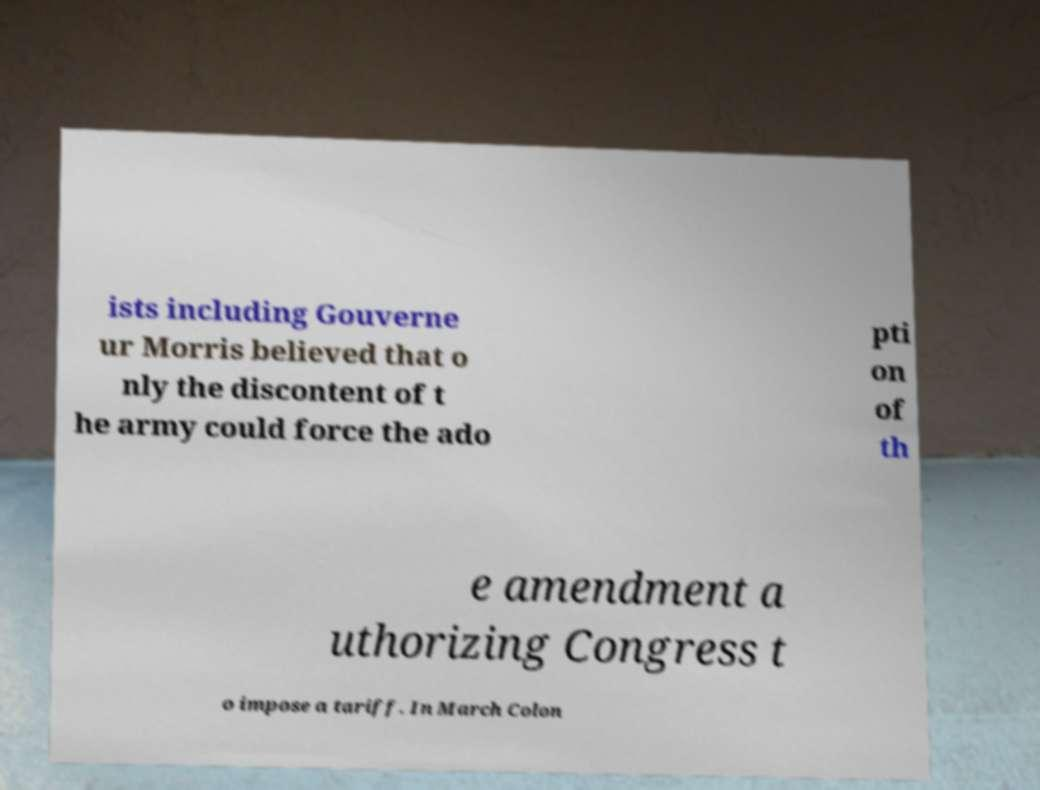There's text embedded in this image that I need extracted. Can you transcribe it verbatim? ists including Gouverne ur Morris believed that o nly the discontent of t he army could force the ado pti on of th e amendment a uthorizing Congress t o impose a tariff. In March Colon 